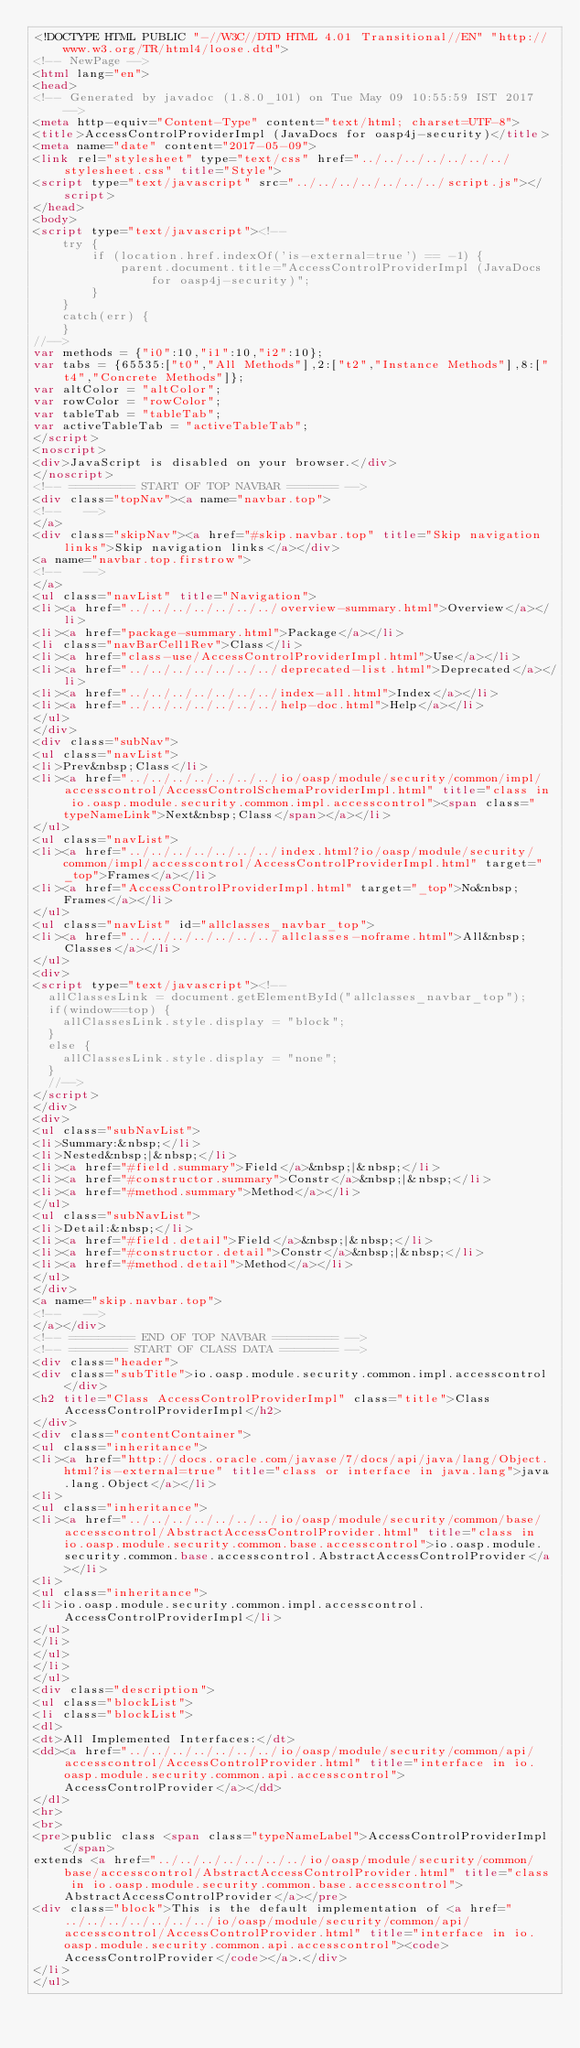<code> <loc_0><loc_0><loc_500><loc_500><_HTML_><!DOCTYPE HTML PUBLIC "-//W3C//DTD HTML 4.01 Transitional//EN" "http://www.w3.org/TR/html4/loose.dtd">
<!-- NewPage -->
<html lang="en">
<head>
<!-- Generated by javadoc (1.8.0_101) on Tue May 09 10:55:59 IST 2017 -->
<meta http-equiv="Content-Type" content="text/html; charset=UTF-8">
<title>AccessControlProviderImpl (JavaDocs for oasp4j-security)</title>
<meta name="date" content="2017-05-09">
<link rel="stylesheet" type="text/css" href="../../../../../../../stylesheet.css" title="Style">
<script type="text/javascript" src="../../../../../../../script.js"></script>
</head>
<body>
<script type="text/javascript"><!--
    try {
        if (location.href.indexOf('is-external=true') == -1) {
            parent.document.title="AccessControlProviderImpl (JavaDocs for oasp4j-security)";
        }
    }
    catch(err) {
    }
//-->
var methods = {"i0":10,"i1":10,"i2":10};
var tabs = {65535:["t0","All Methods"],2:["t2","Instance Methods"],8:["t4","Concrete Methods"]};
var altColor = "altColor";
var rowColor = "rowColor";
var tableTab = "tableTab";
var activeTableTab = "activeTableTab";
</script>
<noscript>
<div>JavaScript is disabled on your browser.</div>
</noscript>
<!-- ========= START OF TOP NAVBAR ======= -->
<div class="topNav"><a name="navbar.top">
<!--   -->
</a>
<div class="skipNav"><a href="#skip.navbar.top" title="Skip navigation links">Skip navigation links</a></div>
<a name="navbar.top.firstrow">
<!--   -->
</a>
<ul class="navList" title="Navigation">
<li><a href="../../../../../../../overview-summary.html">Overview</a></li>
<li><a href="package-summary.html">Package</a></li>
<li class="navBarCell1Rev">Class</li>
<li><a href="class-use/AccessControlProviderImpl.html">Use</a></li>
<li><a href="../../../../../../../deprecated-list.html">Deprecated</a></li>
<li><a href="../../../../../../../index-all.html">Index</a></li>
<li><a href="../../../../../../../help-doc.html">Help</a></li>
</ul>
</div>
<div class="subNav">
<ul class="navList">
<li>Prev&nbsp;Class</li>
<li><a href="../../../../../../../io/oasp/module/security/common/impl/accesscontrol/AccessControlSchemaProviderImpl.html" title="class in io.oasp.module.security.common.impl.accesscontrol"><span class="typeNameLink">Next&nbsp;Class</span></a></li>
</ul>
<ul class="navList">
<li><a href="../../../../../../../index.html?io/oasp/module/security/common/impl/accesscontrol/AccessControlProviderImpl.html" target="_top">Frames</a></li>
<li><a href="AccessControlProviderImpl.html" target="_top">No&nbsp;Frames</a></li>
</ul>
<ul class="navList" id="allclasses_navbar_top">
<li><a href="../../../../../../../allclasses-noframe.html">All&nbsp;Classes</a></li>
</ul>
<div>
<script type="text/javascript"><!--
  allClassesLink = document.getElementById("allclasses_navbar_top");
  if(window==top) {
    allClassesLink.style.display = "block";
  }
  else {
    allClassesLink.style.display = "none";
  }
  //-->
</script>
</div>
<div>
<ul class="subNavList">
<li>Summary:&nbsp;</li>
<li>Nested&nbsp;|&nbsp;</li>
<li><a href="#field.summary">Field</a>&nbsp;|&nbsp;</li>
<li><a href="#constructor.summary">Constr</a>&nbsp;|&nbsp;</li>
<li><a href="#method.summary">Method</a></li>
</ul>
<ul class="subNavList">
<li>Detail:&nbsp;</li>
<li><a href="#field.detail">Field</a>&nbsp;|&nbsp;</li>
<li><a href="#constructor.detail">Constr</a>&nbsp;|&nbsp;</li>
<li><a href="#method.detail">Method</a></li>
</ul>
</div>
<a name="skip.navbar.top">
<!--   -->
</a></div>
<!-- ========= END OF TOP NAVBAR ========= -->
<!-- ======== START OF CLASS DATA ======== -->
<div class="header">
<div class="subTitle">io.oasp.module.security.common.impl.accesscontrol</div>
<h2 title="Class AccessControlProviderImpl" class="title">Class AccessControlProviderImpl</h2>
</div>
<div class="contentContainer">
<ul class="inheritance">
<li><a href="http://docs.oracle.com/javase/7/docs/api/java/lang/Object.html?is-external=true" title="class or interface in java.lang">java.lang.Object</a></li>
<li>
<ul class="inheritance">
<li><a href="../../../../../../../io/oasp/module/security/common/base/accesscontrol/AbstractAccessControlProvider.html" title="class in io.oasp.module.security.common.base.accesscontrol">io.oasp.module.security.common.base.accesscontrol.AbstractAccessControlProvider</a></li>
<li>
<ul class="inheritance">
<li>io.oasp.module.security.common.impl.accesscontrol.AccessControlProviderImpl</li>
</ul>
</li>
</ul>
</li>
</ul>
<div class="description">
<ul class="blockList">
<li class="blockList">
<dl>
<dt>All Implemented Interfaces:</dt>
<dd><a href="../../../../../../../io/oasp/module/security/common/api/accesscontrol/AccessControlProvider.html" title="interface in io.oasp.module.security.common.api.accesscontrol">AccessControlProvider</a></dd>
</dl>
<hr>
<br>
<pre>public class <span class="typeNameLabel">AccessControlProviderImpl</span>
extends <a href="../../../../../../../io/oasp/module/security/common/base/accesscontrol/AbstractAccessControlProvider.html" title="class in io.oasp.module.security.common.base.accesscontrol">AbstractAccessControlProvider</a></pre>
<div class="block">This is the default implementation of <a href="../../../../../../../io/oasp/module/security/common/api/accesscontrol/AccessControlProvider.html" title="interface in io.oasp.module.security.common.api.accesscontrol"><code>AccessControlProvider</code></a>.</div>
</li>
</ul></code> 